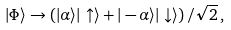Convert formula to latex. <formula><loc_0><loc_0><loc_500><loc_500>| \Phi \rangle \rightarrow \left ( | \alpha \rangle | \uparrow \rangle + | - \alpha \rangle | \downarrow \rangle \right ) / \sqrt { 2 } \, ,</formula> 